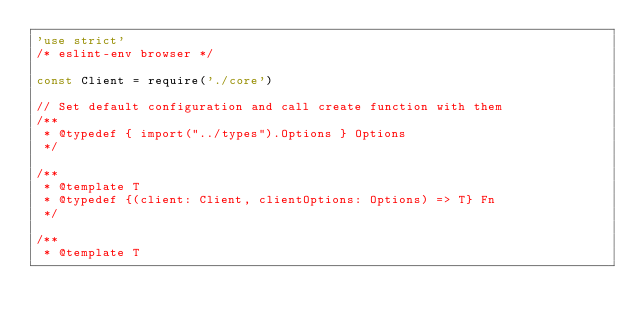Convert code to text. <code><loc_0><loc_0><loc_500><loc_500><_JavaScript_>'use strict'
/* eslint-env browser */

const Client = require('./core')

// Set default configuration and call create function with them
/**
 * @typedef { import("../types").Options } Options
 */

/**
 * @template T
 * @typedef {(client: Client, clientOptions: Options) => T} Fn
 */

/**
 * @template T</code> 